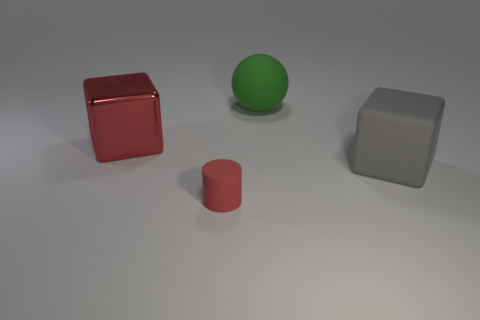Add 4 blue metal objects. How many objects exist? 8 Subtract all spheres. How many objects are left? 3 Subtract all cylinders. Subtract all large green matte things. How many objects are left? 2 Add 2 big red shiny objects. How many big red shiny objects are left? 3 Add 3 tiny purple metal objects. How many tiny purple metal objects exist? 3 Subtract 0 yellow cubes. How many objects are left? 4 